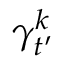<formula> <loc_0><loc_0><loc_500><loc_500>\gamma _ { t ^ { \prime } } ^ { k }</formula> 